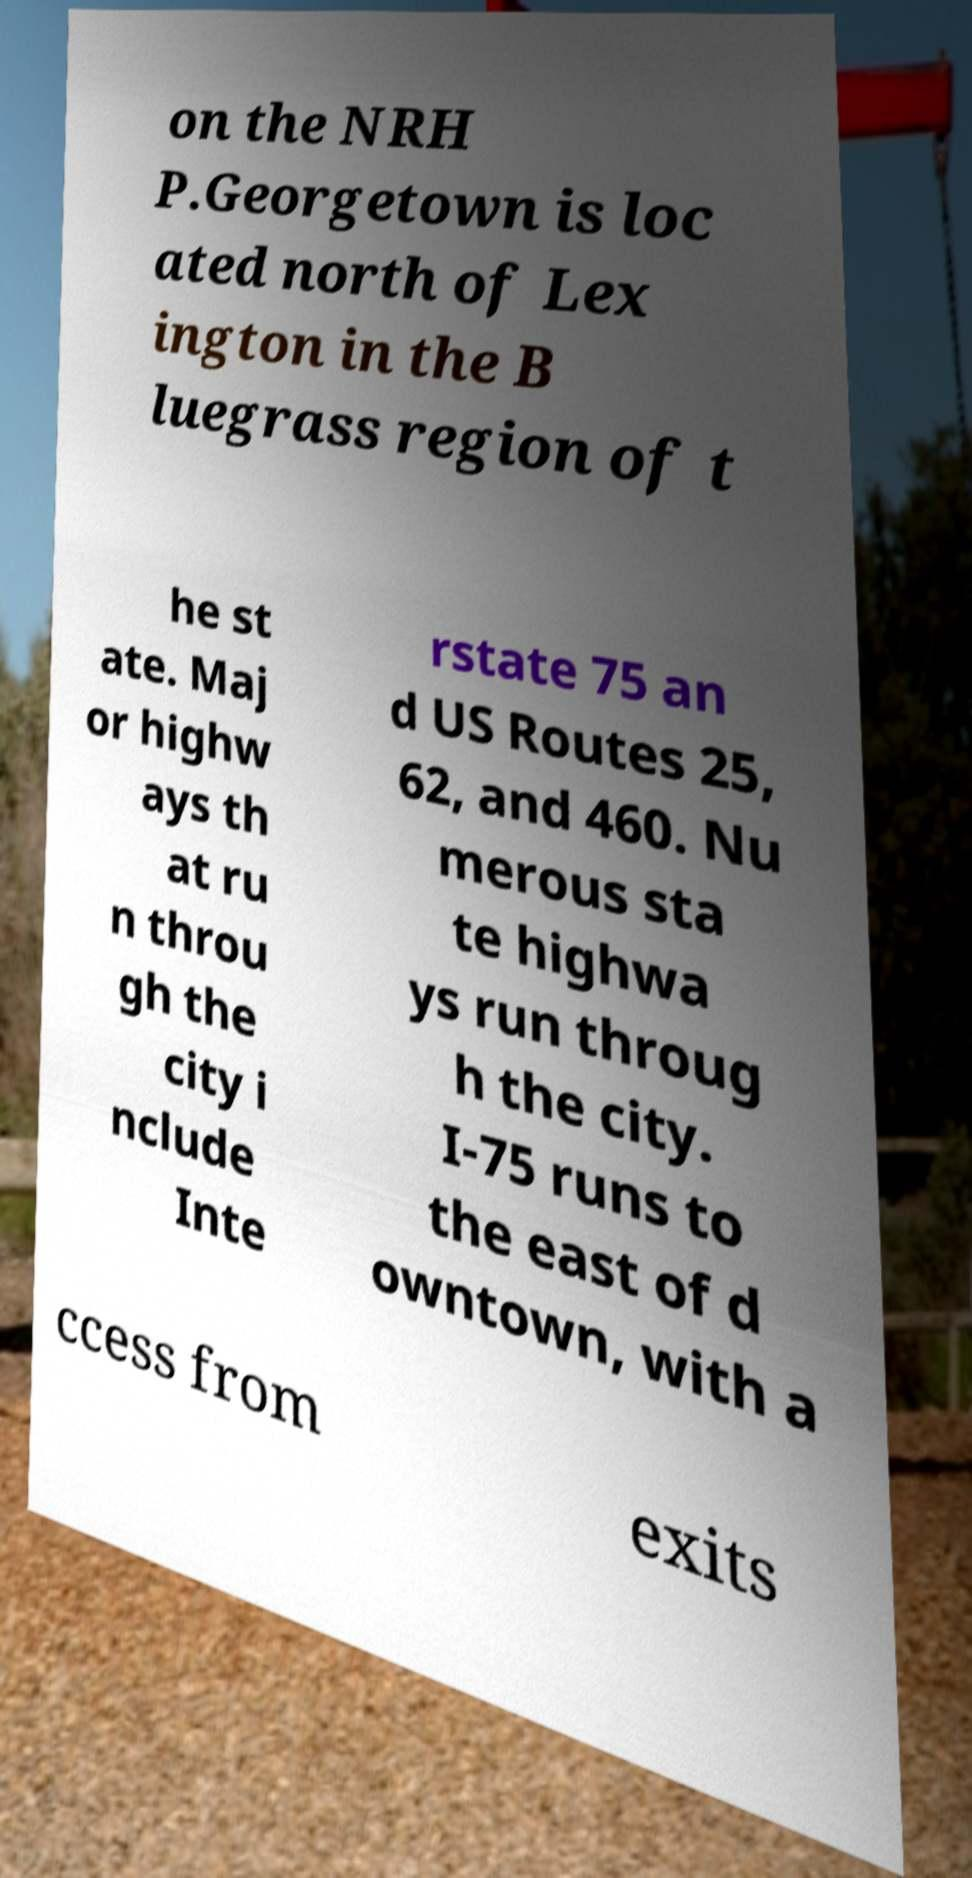There's text embedded in this image that I need extracted. Can you transcribe it verbatim? on the NRH P.Georgetown is loc ated north of Lex ington in the B luegrass region of t he st ate. Maj or highw ays th at ru n throu gh the city i nclude Inte rstate 75 an d US Routes 25, 62, and 460. Nu merous sta te highwa ys run throug h the city. I-75 runs to the east of d owntown, with a ccess from exits 